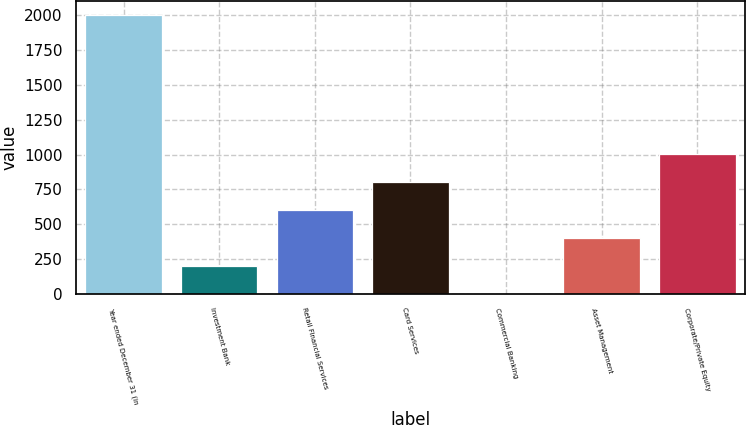<chart> <loc_0><loc_0><loc_500><loc_500><bar_chart><fcel>Year ended December 31 (in<fcel>Investment Bank<fcel>Retail Financial Services<fcel>Card Services<fcel>Commercial Banking<fcel>Asset Management<fcel>Corporate/Private Equity<nl><fcel>2006<fcel>201.5<fcel>602.5<fcel>803<fcel>1<fcel>402<fcel>1003.5<nl></chart> 